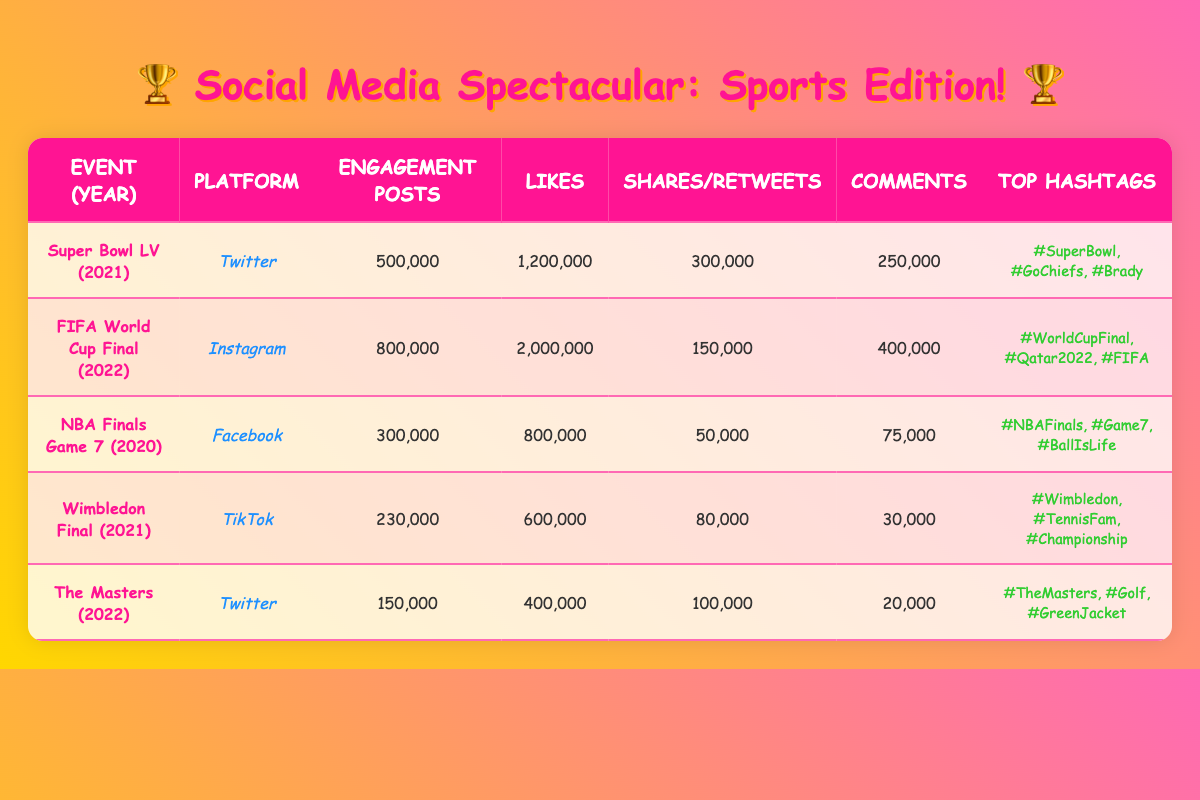What sporting event had the highest engagement posts? By examining the "Engagement Posts" column, we see that the FIFA World Cup Final had the highest number with 800,000 posts, significantly more than any other event listed.
Answer: FIFA World Cup Final Which platform was utilized for the Super Bowl LV? The table directly indicates that for Super Bowl LV, the platform used for engagement was Twitter.
Answer: Twitter How many total likes were received across all events listed? Adding up the likes from each event: 1,200,000 (Super Bowl LV) + 2,000,000 (FIFA World Cup Final) + 800,000 (NBA Finals Game 7) + 600,000 (Wimbledon Final) + 400,000 (The Masters) gives a total of 5,000,000 likes.
Answer: 5,000,000 What is the difference in engagement posts between the FIFA World Cup Final and the Wimbledon Final? The FIFA World Cup Final had 800,000 engagement posts while the Wimbledon Final had 230,000. Thus, the difference is 800,000 - 230,000 = 570,000 posts.
Answer: 570,000 Did Instagram have more shares compared to Facebook? Instagram had 150,000 shares for the FIFA World Cup Final, while Facebook had 50,000 shares for the NBA Finals Game 7. Since 150,000 is greater than 50,000, the answer is yes.
Answer: Yes Which event had the least number of comments, and how many were there? Looking at the "Comments" column, the Wimbledon Final had the least with only 30,000 comments.
Answer: Wimbledon Final, 30,000 What is the average number of likes for the events listed in Twitter? The events on Twitter are Super Bowl LV (1,200,000 likes) and The Masters (400,000 likes). The average is calculated as (1,200,000 + 400,000) / 2 = 800,000.
Answer: 800,000 Which event had the highest number of comments, and what was that number? A quick glance at the "Comments" column shows the FIFA World Cup Final with 400,000 comments, the highest among all events.
Answer: FIFA World Cup Final, 400,000 Was the engagement for The Masters higher than for the NBA Finals Game 7? Comparing the engagement posts, The Masters had 150,000 while NBA Finals Game 7 had 300,000. Since 150,000 is less than 300,000, the answer is no.
Answer: No 